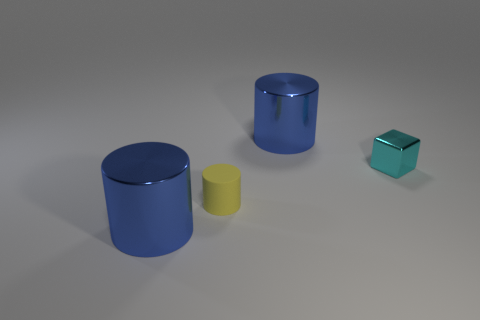Add 1 yellow rubber cylinders. How many objects exist? 5 Subtract all yellow cylinders. How many cylinders are left? 2 Subtract all shiny cylinders. How many cylinders are left? 1 Subtract 0 purple cylinders. How many objects are left? 4 Subtract all cylinders. How many objects are left? 1 Subtract 1 blocks. How many blocks are left? 0 Subtract all green cylinders. Subtract all brown spheres. How many cylinders are left? 3 Subtract all cyan cubes. How many yellow cylinders are left? 1 Subtract all tiny cyan metallic objects. Subtract all metallic things. How many objects are left? 0 Add 2 matte objects. How many matte objects are left? 3 